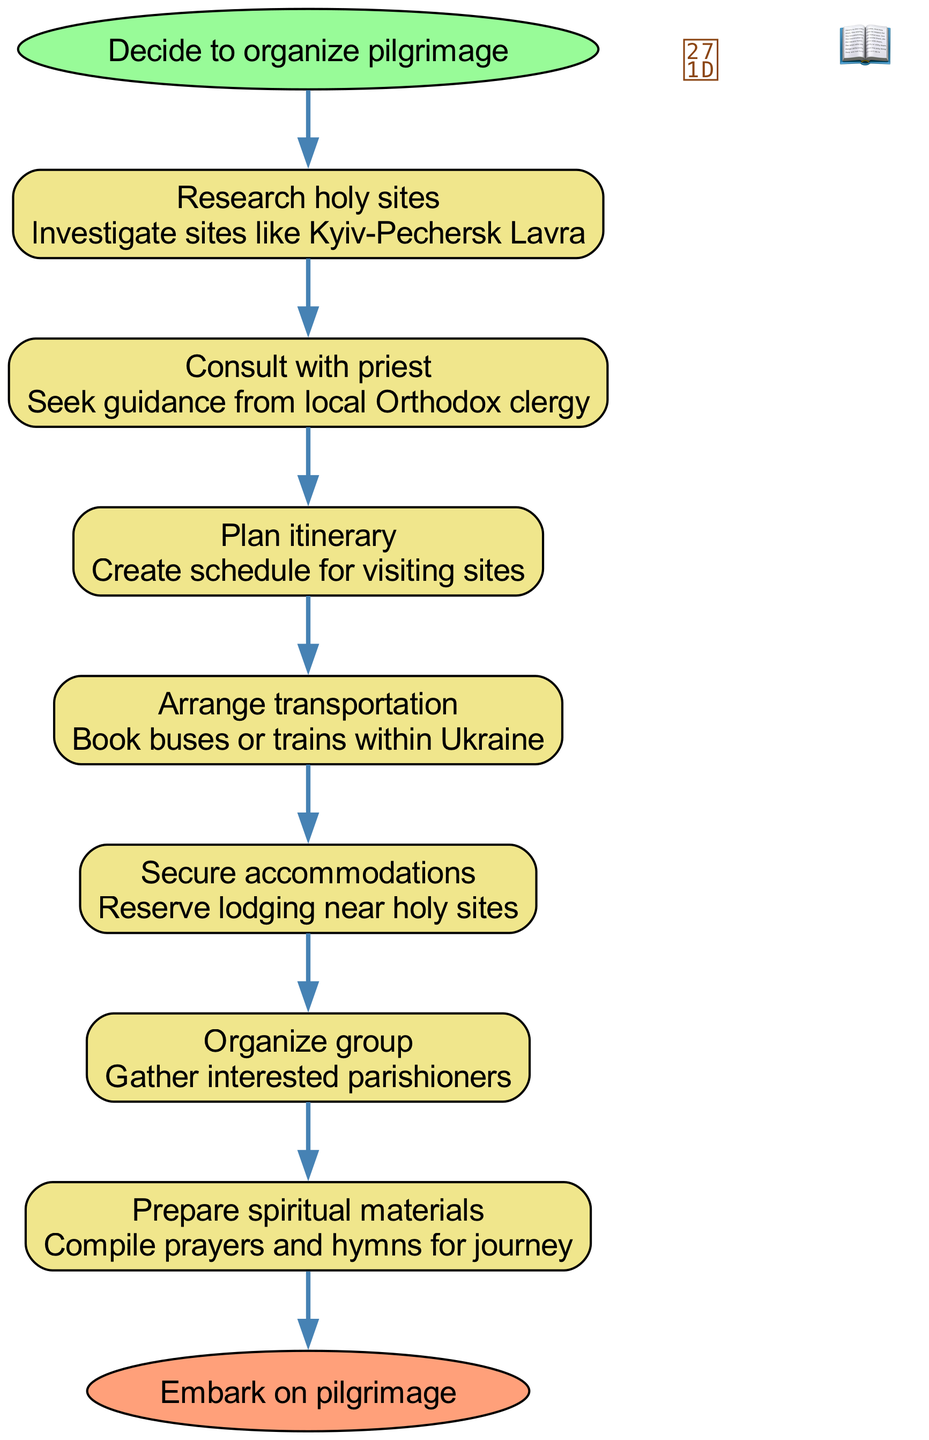What is the starting point of the pilgrimage organization process? The diagram clearly labels the starting point as "Decide to organize pilgrimage," indicating the initial decision-making step before any other actions are taken.
Answer: Decide to organize pilgrimage How many steps are involved in the pilgrimage organization process? By counting the nodes labeled for the steps in the diagram, we find a total of 7 distinct steps leading to the end of the process.
Answer: 7 What is the last step before embarking on the pilgrimage? The last node before reaching the endpoint "Embark on pilgrimage" is "Prepare spiritual materials," which is crucial for the journey as it involves compiling prayers and hymns.
Answer: Prepare spiritual materials Which step involves booking travel? The step that focuses on travel arrangements is "Arrange transportation," which specifically mentions booking buses or trains for the pilgrimage.
Answer: Arrange transportation What is the relationship between "Research holy sites" and "Consult with priest"? "Consult with priest" directly follows "Research holy sites," indicating that once research is done, the next action is to seek guidance from clergy, suggesting a sequence of input gathering followed by advisory support.
Answer: Sequence/Directly follows What materials are prepared for the journey? The step that details the materials is "Prepare spiritual materials," which specifies the compilation of prayers and hymns that participants will use during the pilgrimage.
Answer: Prayers and hymns Who is consulted for spiritual guidance? The diagram indicates that local Orthodox clergy are consulted for guidance, specifically in the step titled "Consult with priest."
Answer: Local Orthodox clergy What precedes the arrangement of accommodations? The step that leads immediately before "Secure accommodations" is "Organize group," which highlights the necessity of gathering interested parishioners before making lodging arrangements.
Answer: Organize group 